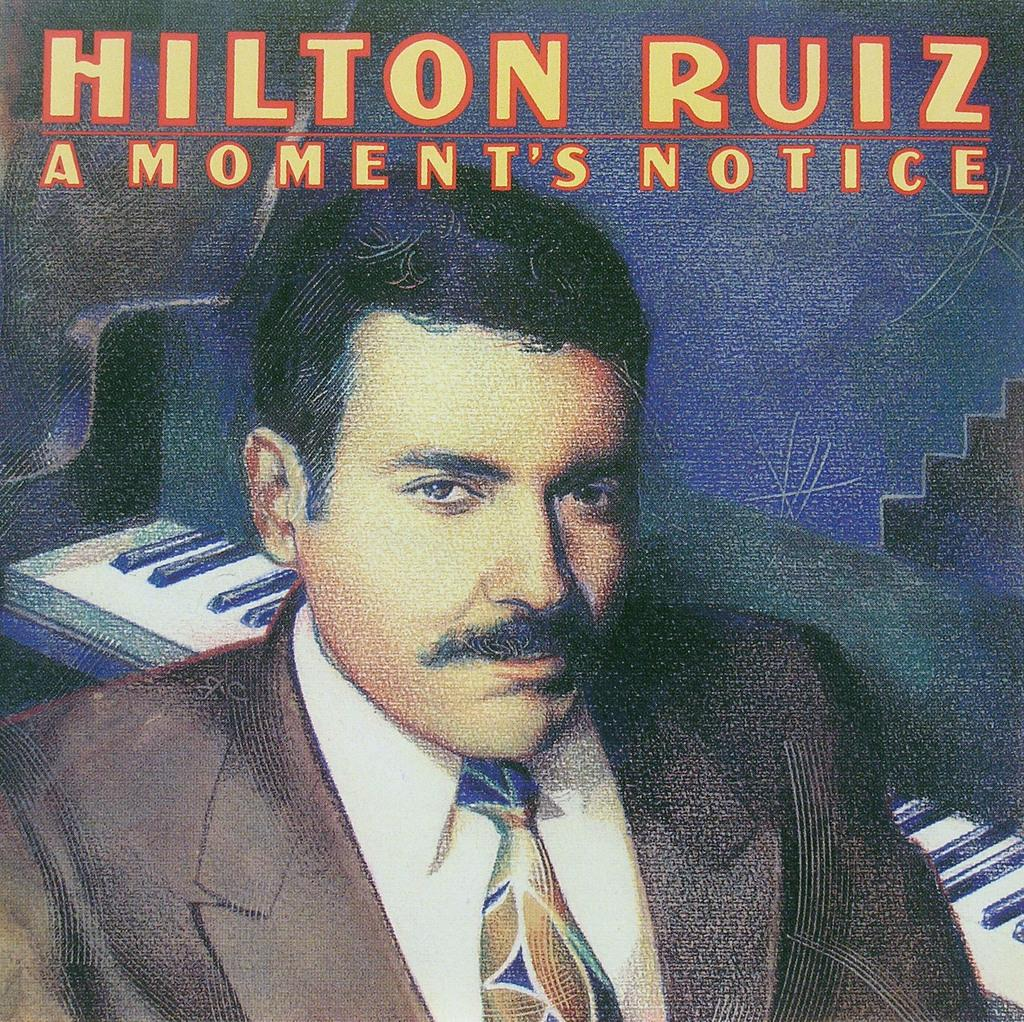Who is the main subject in the foreground of the poster? There is a man in the foreground of the poster. What is the man wearing in the poster? The man is wearing a suit in the poster. What object is behind the man in the poster? The man is in front of a piano in the poster. What can be seen at the top of the poster? There is text on the top of the poster. What type of underwear is the man wearing in the poster? There is no information about the man's underwear in the image, as the focus is on his suit and the piano behind him. 